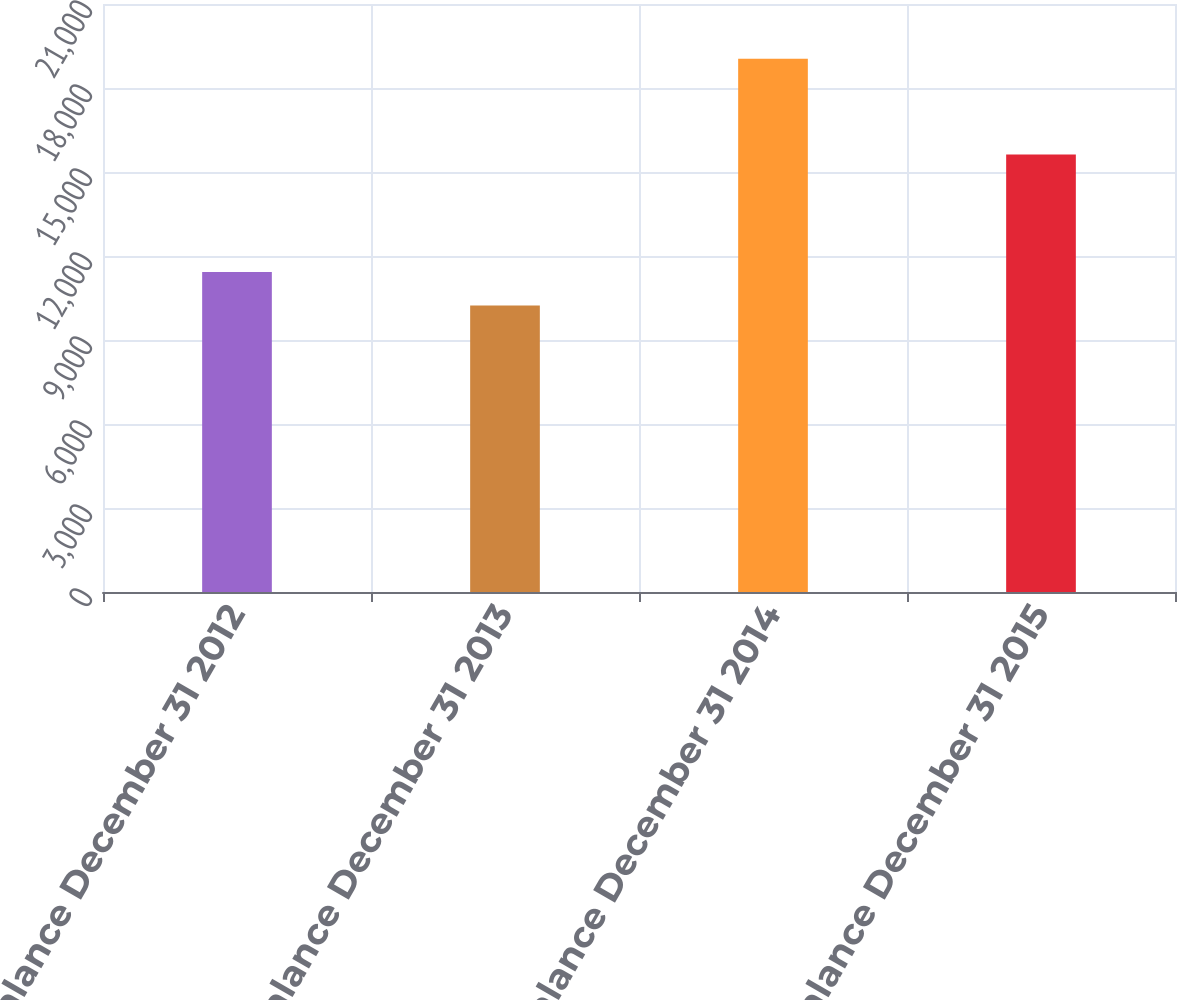Convert chart to OTSL. <chart><loc_0><loc_0><loc_500><loc_500><bar_chart><fcel>Balance December 31 2012<fcel>Balance December 31 2013<fcel>Balance December 31 2014<fcel>Balance December 31 2015<nl><fcel>11433<fcel>10231<fcel>19047<fcel>15627<nl></chart> 